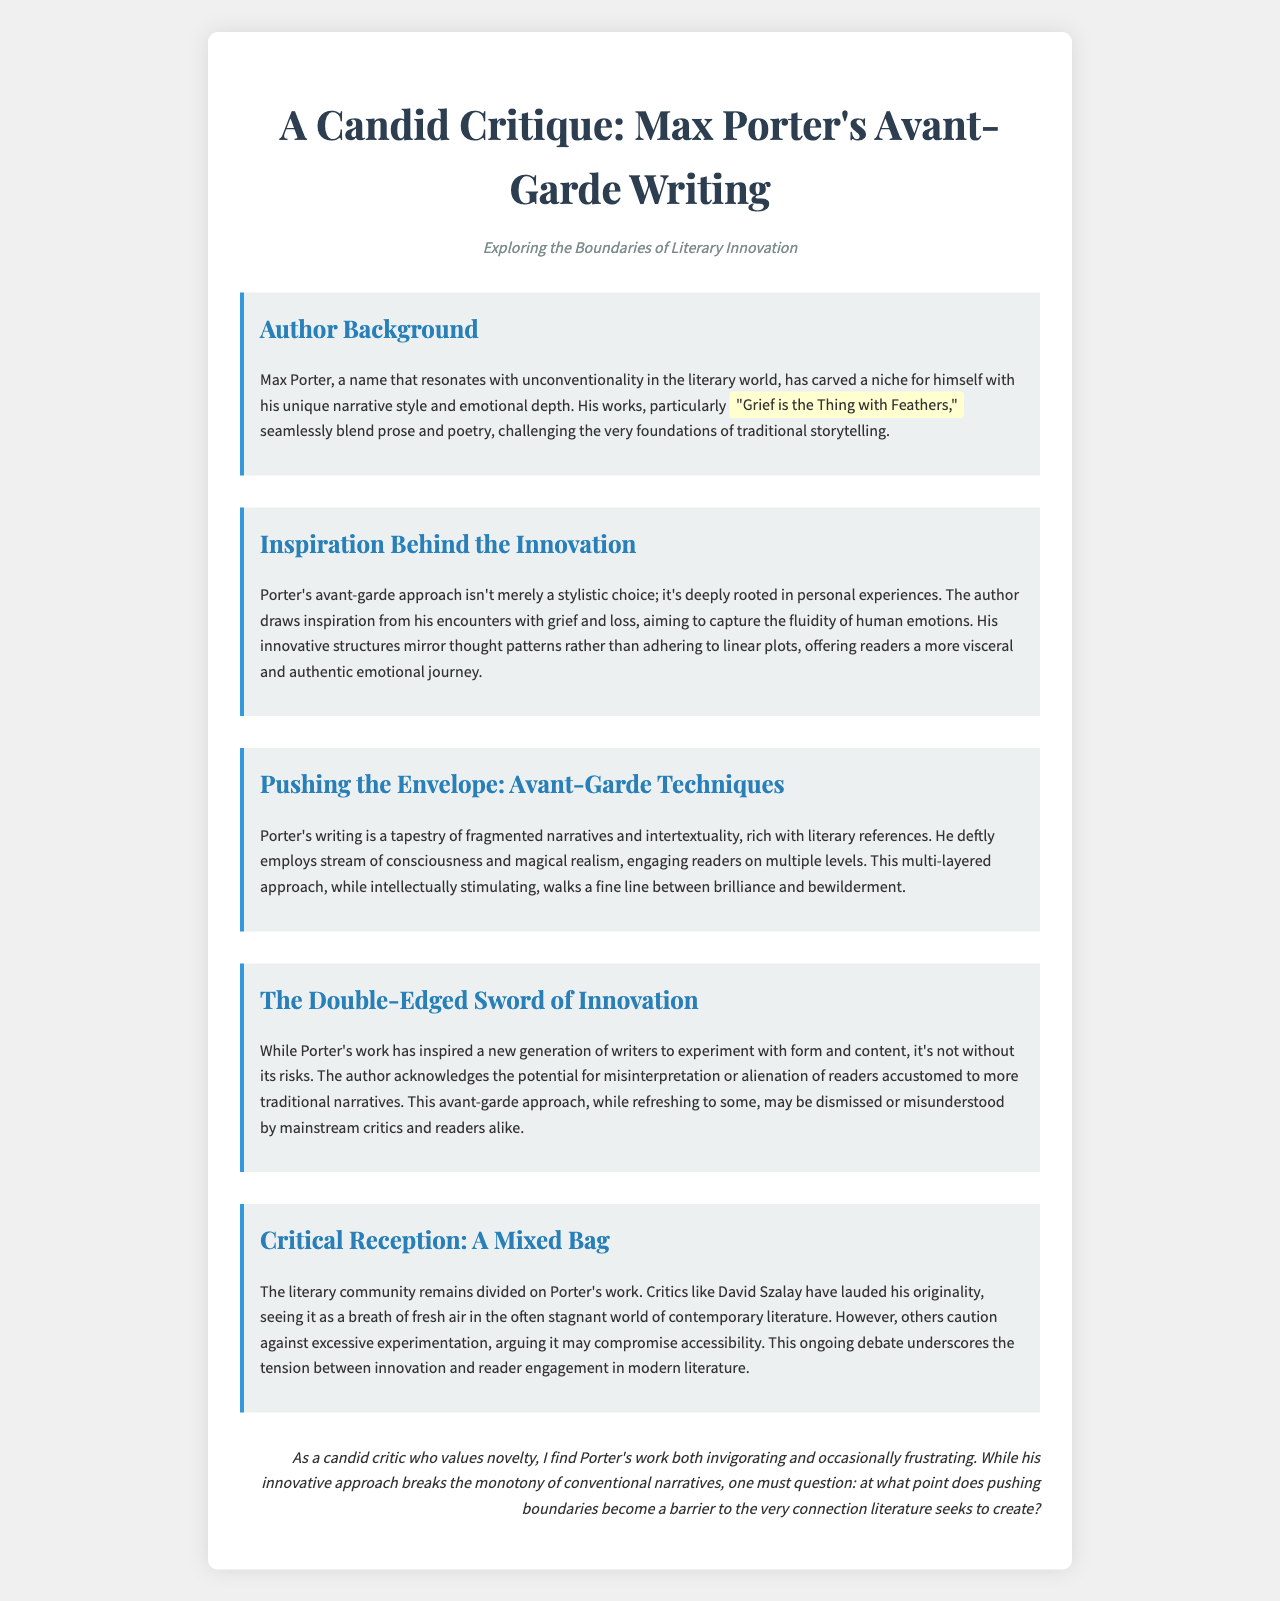What is the title of Max Porter's acclaimed work? The title of Max Porter's work is mentioned as "Grief is the Thing with Feathers."
Answer: "Grief is the Thing with Feathers" What narrative style does Max Porter challenge? The document mentions that Max Porter's works challenge the foundations of traditional storytelling.
Answer: Traditional storytelling What emotion primarily influences Porter's writing? The document states that Porter draws inspiration from his encounters with grief and loss.
Answer: Grief and loss Which literary technique does Porter frequently use? The document highlights that Porter employs stream of consciousness as one of his techniques.
Answer: Stream of consciousness What is a potential risk of avant-garde writing according to Porter? The document notes that there is potential for misinterpretation or alienation of readers in avant-garde writing.
Answer: Misinterpretation or alienation Who praised Porter's originality? The document identifies David Szalay as a critic who has lauded Porter's originality.
Answer: David Szalay What does the document suggest is a tension in modern literature? The ongoing debate around excessive experimentation versus accessibility indicates a tension in modern literature.
Answer: Innovation and reader engagement What is the author's stance as a critic toward Porter's work? The author expresses a mixed reaction, finding Porter's work invigorating yet occasionally frustrating.
Answer: Invigorating and frustrating 